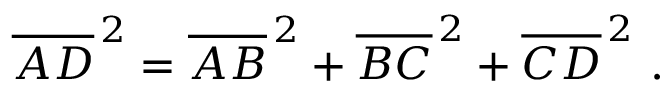Convert formula to latex. <formula><loc_0><loc_0><loc_500><loc_500>{ \overline { A D } } ^ { \, 2 } = { \overline { A B } } ^ { \, 2 } + { \overline { B C } } ^ { \, 2 } + { \overline { C D } } ^ { \, 2 } \ .</formula> 